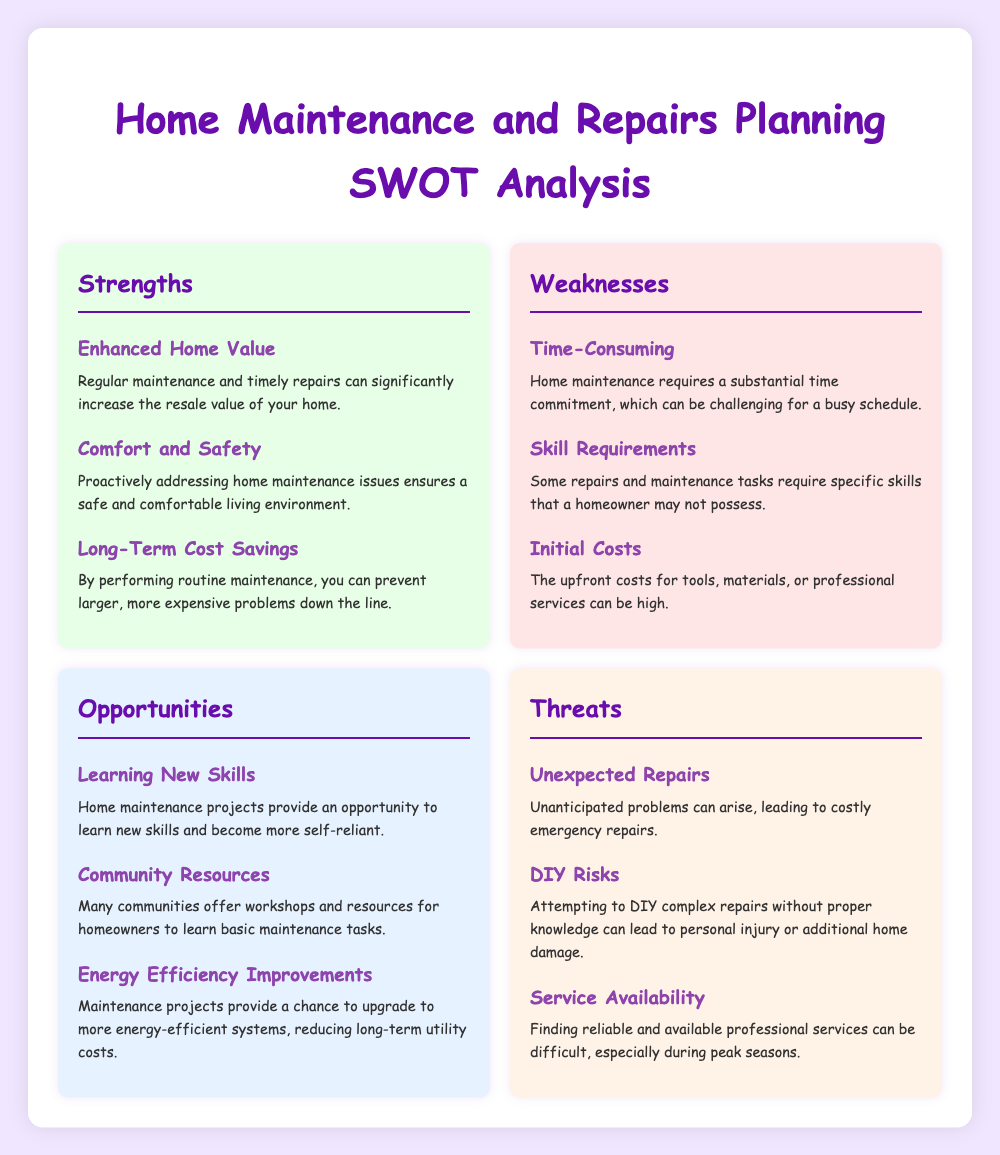What is one strength of home maintenance? The document lists "Enhanced Home Value" as a strength, indicating that regular maintenance can increase the resale value of a home.
Answer: Enhanced Home Value What is one weakness related to home maintenance? "Time-Consuming" is identified as a weakness, highlighting a substantial time commitment needed for home maintenance.
Answer: Time-Consuming What is a noted opportunity for homeowners? "Learning New Skills" is mentioned as an opportunity, allowing homeowners to become more self-reliant through maintenance projects.
Answer: Learning New Skills What type of risks are associated with DIY repairs? The document mentions "DIY Risks," indicating potential personal injury or additional damage due to improper repairs.
Answer: DIY Risks How many strengths are listed in the document? The document provides three strengths related to home maintenance and repairs planning.
Answer: 3 What can unexpected issues lead to? According to the document, unexpected repairs can lead to costly emergency repairs.
Answer: Costly emergency repairs What is suggested as a means to improve energy efficiency? The document mentions "Energy Efficiency Improvements" as an opportunity during maintenance projects.
Answer: Energy Efficiency Improvements What is a potential threat when looking for services? "Service Availability" is noted as a threat, emphasizing the difficulty in finding reliable professionals during peak seasons.
Answer: Service Availability 